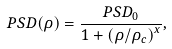Convert formula to latex. <formula><loc_0><loc_0><loc_500><loc_500>P S D ( \rho ) = \frac { P S D _ { 0 } } { 1 + { ( \rho / \rho _ { c } ) } ^ { x } } ,</formula> 